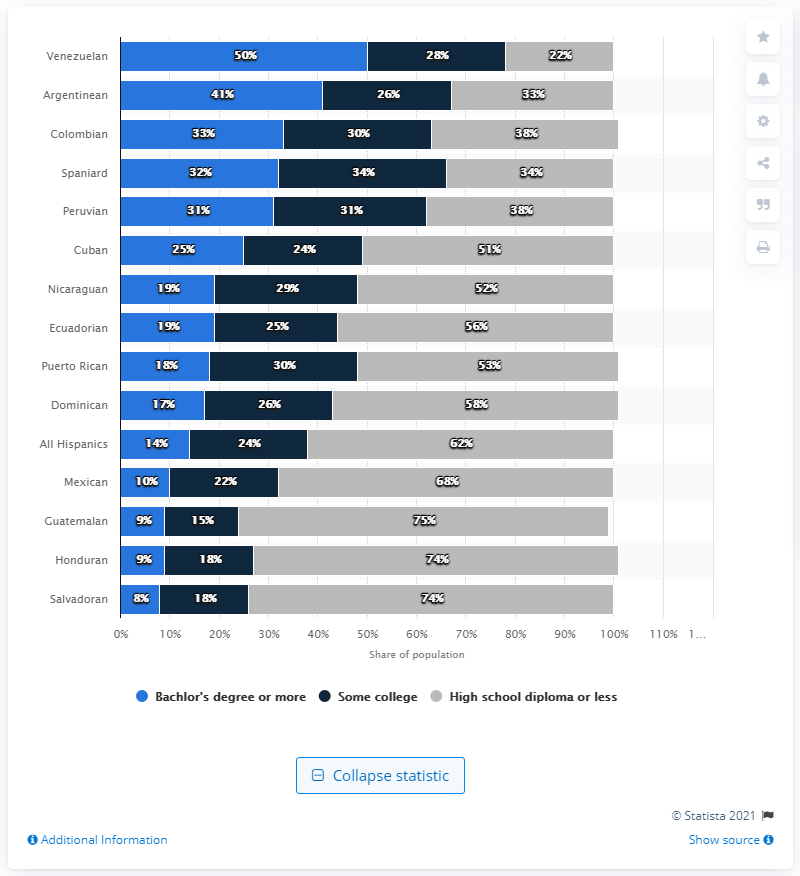Highlight a few significant elements in this photo. The Salvadoran Bachelor's degree and Hispanic Bachelor's degree differ in that the Salvadoran Bachelor's degree is specific to one college, while the Hispanic Bachelor's degree is awarded to all Hispanic individuals who have completed a bachelor's degree. 